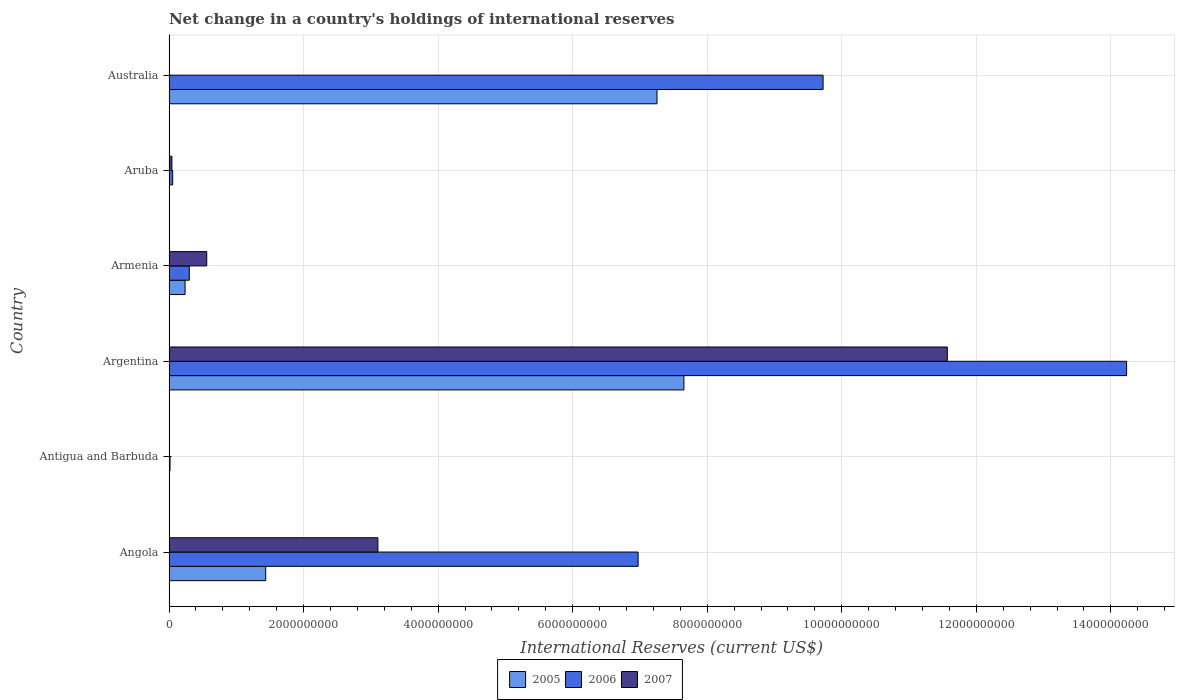How many groups of bars are there?
Keep it short and to the point. 6. How many bars are there on the 2nd tick from the top?
Offer a terse response. 2. What is the label of the 4th group of bars from the top?
Your answer should be very brief. Argentina. What is the international reserves in 2007 in Angola?
Provide a succinct answer. 3.10e+09. Across all countries, what is the maximum international reserves in 2006?
Keep it short and to the point. 1.42e+1. What is the total international reserves in 2007 in the graph?
Ensure brevity in your answer.  1.53e+1. What is the difference between the international reserves in 2007 in Angola and that in Aruba?
Ensure brevity in your answer.  3.06e+09. What is the difference between the international reserves in 2006 in Antigua and Barbuda and the international reserves in 2005 in Australia?
Your answer should be very brief. -7.24e+09. What is the average international reserves in 2006 per country?
Keep it short and to the point. 5.22e+09. What is the difference between the international reserves in 2007 and international reserves in 2006 in Aruba?
Keep it short and to the point. -1.20e+07. What is the ratio of the international reserves in 2007 in Angola to that in Argentina?
Ensure brevity in your answer.  0.27. Is the international reserves in 2005 in Argentina less than that in Australia?
Provide a short and direct response. No. Is the difference between the international reserves in 2007 in Antigua and Barbuda and Argentina greater than the difference between the international reserves in 2006 in Antigua and Barbuda and Argentina?
Your response must be concise. Yes. What is the difference between the highest and the second highest international reserves in 2006?
Provide a short and direct response. 4.51e+09. What is the difference between the highest and the lowest international reserves in 2007?
Give a very brief answer. 1.16e+1. In how many countries, is the international reserves in 2007 greater than the average international reserves in 2007 taken over all countries?
Give a very brief answer. 2. Is it the case that in every country, the sum of the international reserves in 2007 and international reserves in 2005 is greater than the international reserves in 2006?
Offer a terse response. No. How many countries are there in the graph?
Your answer should be compact. 6. What is the difference between two consecutive major ticks on the X-axis?
Provide a succinct answer. 2.00e+09. Are the values on the major ticks of X-axis written in scientific E-notation?
Keep it short and to the point. No. Does the graph contain grids?
Make the answer very short. Yes. How many legend labels are there?
Offer a very short reply. 3. How are the legend labels stacked?
Give a very brief answer. Horizontal. What is the title of the graph?
Give a very brief answer. Net change in a country's holdings of international reserves. Does "1964" appear as one of the legend labels in the graph?
Your response must be concise. No. What is the label or title of the X-axis?
Offer a very short reply. International Reserves (current US$). What is the International Reserves (current US$) in 2005 in Angola?
Ensure brevity in your answer.  1.44e+09. What is the International Reserves (current US$) in 2006 in Angola?
Your answer should be compact. 6.97e+09. What is the International Reserves (current US$) of 2007 in Angola?
Provide a short and direct response. 3.10e+09. What is the International Reserves (current US$) of 2005 in Antigua and Barbuda?
Provide a succinct answer. 7.24e+06. What is the International Reserves (current US$) in 2006 in Antigua and Barbuda?
Keep it short and to the point. 1.54e+07. What is the International Reserves (current US$) of 2007 in Antigua and Barbuda?
Ensure brevity in your answer.  3.68e+05. What is the International Reserves (current US$) in 2005 in Argentina?
Make the answer very short. 7.65e+09. What is the International Reserves (current US$) of 2006 in Argentina?
Provide a succinct answer. 1.42e+1. What is the International Reserves (current US$) in 2007 in Argentina?
Provide a short and direct response. 1.16e+1. What is the International Reserves (current US$) in 2005 in Armenia?
Offer a terse response. 2.39e+08. What is the International Reserves (current US$) of 2006 in Armenia?
Make the answer very short. 3.02e+08. What is the International Reserves (current US$) in 2007 in Armenia?
Give a very brief answer. 5.61e+08. What is the International Reserves (current US$) of 2006 in Aruba?
Ensure brevity in your answer.  5.51e+07. What is the International Reserves (current US$) in 2007 in Aruba?
Your answer should be very brief. 4.32e+07. What is the International Reserves (current US$) in 2005 in Australia?
Your response must be concise. 7.25e+09. What is the International Reserves (current US$) in 2006 in Australia?
Offer a terse response. 9.72e+09. What is the International Reserves (current US$) in 2007 in Australia?
Make the answer very short. 0. Across all countries, what is the maximum International Reserves (current US$) in 2005?
Your answer should be compact. 7.65e+09. Across all countries, what is the maximum International Reserves (current US$) in 2006?
Provide a short and direct response. 1.42e+1. Across all countries, what is the maximum International Reserves (current US$) in 2007?
Provide a short and direct response. 1.16e+1. Across all countries, what is the minimum International Reserves (current US$) in 2005?
Give a very brief answer. 0. Across all countries, what is the minimum International Reserves (current US$) in 2006?
Your response must be concise. 1.54e+07. What is the total International Reserves (current US$) of 2005 in the graph?
Keep it short and to the point. 1.66e+1. What is the total International Reserves (current US$) of 2006 in the graph?
Offer a very short reply. 3.13e+1. What is the total International Reserves (current US$) of 2007 in the graph?
Your response must be concise. 1.53e+1. What is the difference between the International Reserves (current US$) of 2005 in Angola and that in Antigua and Barbuda?
Offer a very short reply. 1.43e+09. What is the difference between the International Reserves (current US$) of 2006 in Angola and that in Antigua and Barbuda?
Keep it short and to the point. 6.96e+09. What is the difference between the International Reserves (current US$) of 2007 in Angola and that in Antigua and Barbuda?
Your answer should be very brief. 3.10e+09. What is the difference between the International Reserves (current US$) in 2005 in Angola and that in Argentina?
Your answer should be compact. -6.22e+09. What is the difference between the International Reserves (current US$) of 2006 in Angola and that in Argentina?
Your answer should be compact. -7.26e+09. What is the difference between the International Reserves (current US$) of 2007 in Angola and that in Argentina?
Your response must be concise. -8.46e+09. What is the difference between the International Reserves (current US$) of 2005 in Angola and that in Armenia?
Provide a succinct answer. 1.20e+09. What is the difference between the International Reserves (current US$) in 2006 in Angola and that in Armenia?
Your answer should be compact. 6.67e+09. What is the difference between the International Reserves (current US$) of 2007 in Angola and that in Armenia?
Your answer should be compact. 2.54e+09. What is the difference between the International Reserves (current US$) of 2006 in Angola and that in Aruba?
Offer a terse response. 6.92e+09. What is the difference between the International Reserves (current US$) in 2007 in Angola and that in Aruba?
Provide a succinct answer. 3.06e+09. What is the difference between the International Reserves (current US$) in 2005 in Angola and that in Australia?
Give a very brief answer. -5.82e+09. What is the difference between the International Reserves (current US$) of 2006 in Angola and that in Australia?
Your answer should be compact. -2.75e+09. What is the difference between the International Reserves (current US$) in 2005 in Antigua and Barbuda and that in Argentina?
Ensure brevity in your answer.  -7.65e+09. What is the difference between the International Reserves (current US$) in 2006 in Antigua and Barbuda and that in Argentina?
Your answer should be compact. -1.42e+1. What is the difference between the International Reserves (current US$) of 2007 in Antigua and Barbuda and that in Argentina?
Offer a terse response. -1.16e+1. What is the difference between the International Reserves (current US$) of 2005 in Antigua and Barbuda and that in Armenia?
Keep it short and to the point. -2.31e+08. What is the difference between the International Reserves (current US$) in 2006 in Antigua and Barbuda and that in Armenia?
Ensure brevity in your answer.  -2.86e+08. What is the difference between the International Reserves (current US$) of 2007 in Antigua and Barbuda and that in Armenia?
Provide a succinct answer. -5.61e+08. What is the difference between the International Reserves (current US$) of 2006 in Antigua and Barbuda and that in Aruba?
Your answer should be compact. -3.98e+07. What is the difference between the International Reserves (current US$) in 2007 in Antigua and Barbuda and that in Aruba?
Provide a short and direct response. -4.28e+07. What is the difference between the International Reserves (current US$) in 2005 in Antigua and Barbuda and that in Australia?
Offer a very short reply. -7.25e+09. What is the difference between the International Reserves (current US$) in 2006 in Antigua and Barbuda and that in Australia?
Offer a terse response. -9.71e+09. What is the difference between the International Reserves (current US$) in 2005 in Argentina and that in Armenia?
Make the answer very short. 7.42e+09. What is the difference between the International Reserves (current US$) in 2006 in Argentina and that in Armenia?
Provide a short and direct response. 1.39e+1. What is the difference between the International Reserves (current US$) in 2007 in Argentina and that in Armenia?
Offer a very short reply. 1.10e+1. What is the difference between the International Reserves (current US$) of 2006 in Argentina and that in Aruba?
Offer a very short reply. 1.42e+1. What is the difference between the International Reserves (current US$) of 2007 in Argentina and that in Aruba?
Offer a very short reply. 1.15e+1. What is the difference between the International Reserves (current US$) of 2005 in Argentina and that in Australia?
Ensure brevity in your answer.  4.00e+08. What is the difference between the International Reserves (current US$) in 2006 in Argentina and that in Australia?
Ensure brevity in your answer.  4.51e+09. What is the difference between the International Reserves (current US$) of 2006 in Armenia and that in Aruba?
Your answer should be compact. 2.47e+08. What is the difference between the International Reserves (current US$) of 2007 in Armenia and that in Aruba?
Your answer should be very brief. 5.18e+08. What is the difference between the International Reserves (current US$) of 2005 in Armenia and that in Australia?
Keep it short and to the point. -7.02e+09. What is the difference between the International Reserves (current US$) in 2006 in Armenia and that in Australia?
Offer a terse response. -9.42e+09. What is the difference between the International Reserves (current US$) of 2006 in Aruba and that in Australia?
Your answer should be very brief. -9.67e+09. What is the difference between the International Reserves (current US$) of 2005 in Angola and the International Reserves (current US$) of 2006 in Antigua and Barbuda?
Your response must be concise. 1.42e+09. What is the difference between the International Reserves (current US$) of 2005 in Angola and the International Reserves (current US$) of 2007 in Antigua and Barbuda?
Make the answer very short. 1.44e+09. What is the difference between the International Reserves (current US$) in 2006 in Angola and the International Reserves (current US$) in 2007 in Antigua and Barbuda?
Offer a terse response. 6.97e+09. What is the difference between the International Reserves (current US$) of 2005 in Angola and the International Reserves (current US$) of 2006 in Argentina?
Provide a short and direct response. -1.28e+1. What is the difference between the International Reserves (current US$) in 2005 in Angola and the International Reserves (current US$) in 2007 in Argentina?
Your answer should be very brief. -1.01e+1. What is the difference between the International Reserves (current US$) in 2006 in Angola and the International Reserves (current US$) in 2007 in Argentina?
Make the answer very short. -4.60e+09. What is the difference between the International Reserves (current US$) in 2005 in Angola and the International Reserves (current US$) in 2006 in Armenia?
Ensure brevity in your answer.  1.14e+09. What is the difference between the International Reserves (current US$) of 2005 in Angola and the International Reserves (current US$) of 2007 in Armenia?
Your answer should be very brief. 8.77e+08. What is the difference between the International Reserves (current US$) in 2006 in Angola and the International Reserves (current US$) in 2007 in Armenia?
Ensure brevity in your answer.  6.41e+09. What is the difference between the International Reserves (current US$) of 2005 in Angola and the International Reserves (current US$) of 2006 in Aruba?
Give a very brief answer. 1.38e+09. What is the difference between the International Reserves (current US$) in 2005 in Angola and the International Reserves (current US$) in 2007 in Aruba?
Provide a short and direct response. 1.39e+09. What is the difference between the International Reserves (current US$) in 2006 in Angola and the International Reserves (current US$) in 2007 in Aruba?
Your answer should be compact. 6.93e+09. What is the difference between the International Reserves (current US$) in 2005 in Angola and the International Reserves (current US$) in 2006 in Australia?
Provide a short and direct response. -8.29e+09. What is the difference between the International Reserves (current US$) in 2005 in Antigua and Barbuda and the International Reserves (current US$) in 2006 in Argentina?
Your answer should be very brief. -1.42e+1. What is the difference between the International Reserves (current US$) in 2005 in Antigua and Barbuda and the International Reserves (current US$) in 2007 in Argentina?
Keep it short and to the point. -1.16e+1. What is the difference between the International Reserves (current US$) in 2006 in Antigua and Barbuda and the International Reserves (current US$) in 2007 in Argentina?
Offer a terse response. -1.16e+1. What is the difference between the International Reserves (current US$) of 2005 in Antigua and Barbuda and the International Reserves (current US$) of 2006 in Armenia?
Your answer should be compact. -2.94e+08. What is the difference between the International Reserves (current US$) of 2005 in Antigua and Barbuda and the International Reserves (current US$) of 2007 in Armenia?
Provide a short and direct response. -5.54e+08. What is the difference between the International Reserves (current US$) in 2006 in Antigua and Barbuda and the International Reserves (current US$) in 2007 in Armenia?
Give a very brief answer. -5.46e+08. What is the difference between the International Reserves (current US$) in 2005 in Antigua and Barbuda and the International Reserves (current US$) in 2006 in Aruba?
Make the answer very short. -4.79e+07. What is the difference between the International Reserves (current US$) of 2005 in Antigua and Barbuda and the International Reserves (current US$) of 2007 in Aruba?
Provide a succinct answer. -3.59e+07. What is the difference between the International Reserves (current US$) of 2006 in Antigua and Barbuda and the International Reserves (current US$) of 2007 in Aruba?
Your answer should be compact. -2.78e+07. What is the difference between the International Reserves (current US$) of 2005 in Antigua and Barbuda and the International Reserves (current US$) of 2006 in Australia?
Make the answer very short. -9.72e+09. What is the difference between the International Reserves (current US$) of 2005 in Argentina and the International Reserves (current US$) of 2006 in Armenia?
Ensure brevity in your answer.  7.35e+09. What is the difference between the International Reserves (current US$) in 2005 in Argentina and the International Reserves (current US$) in 2007 in Armenia?
Offer a very short reply. 7.09e+09. What is the difference between the International Reserves (current US$) of 2006 in Argentina and the International Reserves (current US$) of 2007 in Armenia?
Offer a terse response. 1.37e+1. What is the difference between the International Reserves (current US$) in 2005 in Argentina and the International Reserves (current US$) in 2006 in Aruba?
Your answer should be very brief. 7.60e+09. What is the difference between the International Reserves (current US$) in 2005 in Argentina and the International Reserves (current US$) in 2007 in Aruba?
Your response must be concise. 7.61e+09. What is the difference between the International Reserves (current US$) in 2006 in Argentina and the International Reserves (current US$) in 2007 in Aruba?
Offer a terse response. 1.42e+1. What is the difference between the International Reserves (current US$) in 2005 in Argentina and the International Reserves (current US$) in 2006 in Australia?
Provide a succinct answer. -2.07e+09. What is the difference between the International Reserves (current US$) in 2005 in Armenia and the International Reserves (current US$) in 2006 in Aruba?
Provide a short and direct response. 1.84e+08. What is the difference between the International Reserves (current US$) of 2005 in Armenia and the International Reserves (current US$) of 2007 in Aruba?
Your response must be concise. 1.95e+08. What is the difference between the International Reserves (current US$) in 2006 in Armenia and the International Reserves (current US$) in 2007 in Aruba?
Provide a succinct answer. 2.59e+08. What is the difference between the International Reserves (current US$) of 2005 in Armenia and the International Reserves (current US$) of 2006 in Australia?
Your answer should be compact. -9.48e+09. What is the average International Reserves (current US$) in 2005 per country?
Provide a succinct answer. 2.77e+09. What is the average International Reserves (current US$) of 2006 per country?
Your response must be concise. 5.22e+09. What is the average International Reserves (current US$) of 2007 per country?
Make the answer very short. 2.55e+09. What is the difference between the International Reserves (current US$) in 2005 and International Reserves (current US$) in 2006 in Angola?
Your answer should be compact. -5.54e+09. What is the difference between the International Reserves (current US$) in 2005 and International Reserves (current US$) in 2007 in Angola?
Provide a short and direct response. -1.67e+09. What is the difference between the International Reserves (current US$) of 2006 and International Reserves (current US$) of 2007 in Angola?
Your answer should be compact. 3.87e+09. What is the difference between the International Reserves (current US$) of 2005 and International Reserves (current US$) of 2006 in Antigua and Barbuda?
Your answer should be compact. -8.13e+06. What is the difference between the International Reserves (current US$) of 2005 and International Reserves (current US$) of 2007 in Antigua and Barbuda?
Make the answer very short. 6.87e+06. What is the difference between the International Reserves (current US$) in 2006 and International Reserves (current US$) in 2007 in Antigua and Barbuda?
Offer a terse response. 1.50e+07. What is the difference between the International Reserves (current US$) of 2005 and International Reserves (current US$) of 2006 in Argentina?
Provide a short and direct response. -6.58e+09. What is the difference between the International Reserves (current US$) of 2005 and International Reserves (current US$) of 2007 in Argentina?
Ensure brevity in your answer.  -3.92e+09. What is the difference between the International Reserves (current US$) in 2006 and International Reserves (current US$) in 2007 in Argentina?
Your answer should be compact. 2.67e+09. What is the difference between the International Reserves (current US$) in 2005 and International Reserves (current US$) in 2006 in Armenia?
Your response must be concise. -6.30e+07. What is the difference between the International Reserves (current US$) of 2005 and International Reserves (current US$) of 2007 in Armenia?
Your answer should be very brief. -3.22e+08. What is the difference between the International Reserves (current US$) of 2006 and International Reserves (current US$) of 2007 in Armenia?
Your answer should be very brief. -2.59e+08. What is the difference between the International Reserves (current US$) in 2006 and International Reserves (current US$) in 2007 in Aruba?
Your response must be concise. 1.20e+07. What is the difference between the International Reserves (current US$) of 2005 and International Reserves (current US$) of 2006 in Australia?
Your answer should be very brief. -2.47e+09. What is the ratio of the International Reserves (current US$) in 2005 in Angola to that in Antigua and Barbuda?
Your answer should be very brief. 198.69. What is the ratio of the International Reserves (current US$) in 2006 in Angola to that in Antigua and Barbuda?
Ensure brevity in your answer.  453.95. What is the ratio of the International Reserves (current US$) in 2007 in Angola to that in Antigua and Barbuda?
Offer a very short reply. 8426. What is the ratio of the International Reserves (current US$) of 2005 in Angola to that in Argentina?
Your response must be concise. 0.19. What is the ratio of the International Reserves (current US$) in 2006 in Angola to that in Argentina?
Provide a succinct answer. 0.49. What is the ratio of the International Reserves (current US$) in 2007 in Angola to that in Argentina?
Offer a very short reply. 0.27. What is the ratio of the International Reserves (current US$) of 2005 in Angola to that in Armenia?
Make the answer very short. 6.02. What is the ratio of the International Reserves (current US$) in 2006 in Angola to that in Armenia?
Offer a terse response. 23.11. What is the ratio of the International Reserves (current US$) of 2007 in Angola to that in Armenia?
Provide a succinct answer. 5.54. What is the ratio of the International Reserves (current US$) of 2006 in Angola to that in Aruba?
Ensure brevity in your answer.  126.47. What is the ratio of the International Reserves (current US$) of 2007 in Angola to that in Aruba?
Your response must be concise. 71.9. What is the ratio of the International Reserves (current US$) in 2005 in Angola to that in Australia?
Provide a short and direct response. 0.2. What is the ratio of the International Reserves (current US$) of 2006 in Angola to that in Australia?
Give a very brief answer. 0.72. What is the ratio of the International Reserves (current US$) of 2005 in Antigua and Barbuda to that in Argentina?
Offer a very short reply. 0. What is the ratio of the International Reserves (current US$) of 2006 in Antigua and Barbuda to that in Argentina?
Provide a succinct answer. 0. What is the ratio of the International Reserves (current US$) of 2007 in Antigua and Barbuda to that in Argentina?
Offer a very short reply. 0. What is the ratio of the International Reserves (current US$) in 2005 in Antigua and Barbuda to that in Armenia?
Offer a terse response. 0.03. What is the ratio of the International Reserves (current US$) of 2006 in Antigua and Barbuda to that in Armenia?
Provide a succinct answer. 0.05. What is the ratio of the International Reserves (current US$) in 2007 in Antigua and Barbuda to that in Armenia?
Your response must be concise. 0. What is the ratio of the International Reserves (current US$) in 2006 in Antigua and Barbuda to that in Aruba?
Give a very brief answer. 0.28. What is the ratio of the International Reserves (current US$) in 2007 in Antigua and Barbuda to that in Aruba?
Your response must be concise. 0.01. What is the ratio of the International Reserves (current US$) of 2006 in Antigua and Barbuda to that in Australia?
Offer a very short reply. 0. What is the ratio of the International Reserves (current US$) of 2005 in Argentina to that in Armenia?
Provide a short and direct response. 32.07. What is the ratio of the International Reserves (current US$) of 2006 in Argentina to that in Armenia?
Offer a terse response. 47.18. What is the ratio of the International Reserves (current US$) in 2007 in Argentina to that in Armenia?
Your answer should be compact. 20.63. What is the ratio of the International Reserves (current US$) in 2006 in Argentina to that in Aruba?
Offer a very short reply. 258.15. What is the ratio of the International Reserves (current US$) of 2007 in Argentina to that in Aruba?
Your response must be concise. 267.91. What is the ratio of the International Reserves (current US$) of 2005 in Argentina to that in Australia?
Provide a short and direct response. 1.06. What is the ratio of the International Reserves (current US$) of 2006 in Argentina to that in Australia?
Make the answer very short. 1.46. What is the ratio of the International Reserves (current US$) of 2006 in Armenia to that in Aruba?
Your answer should be very brief. 5.47. What is the ratio of the International Reserves (current US$) of 2007 in Armenia to that in Aruba?
Offer a very short reply. 12.99. What is the ratio of the International Reserves (current US$) in 2005 in Armenia to that in Australia?
Make the answer very short. 0.03. What is the ratio of the International Reserves (current US$) of 2006 in Armenia to that in Australia?
Your answer should be very brief. 0.03. What is the ratio of the International Reserves (current US$) of 2006 in Aruba to that in Australia?
Your answer should be very brief. 0.01. What is the difference between the highest and the second highest International Reserves (current US$) of 2005?
Your answer should be compact. 4.00e+08. What is the difference between the highest and the second highest International Reserves (current US$) of 2006?
Keep it short and to the point. 4.51e+09. What is the difference between the highest and the second highest International Reserves (current US$) in 2007?
Make the answer very short. 8.46e+09. What is the difference between the highest and the lowest International Reserves (current US$) in 2005?
Offer a very short reply. 7.65e+09. What is the difference between the highest and the lowest International Reserves (current US$) in 2006?
Make the answer very short. 1.42e+1. What is the difference between the highest and the lowest International Reserves (current US$) in 2007?
Provide a succinct answer. 1.16e+1. 